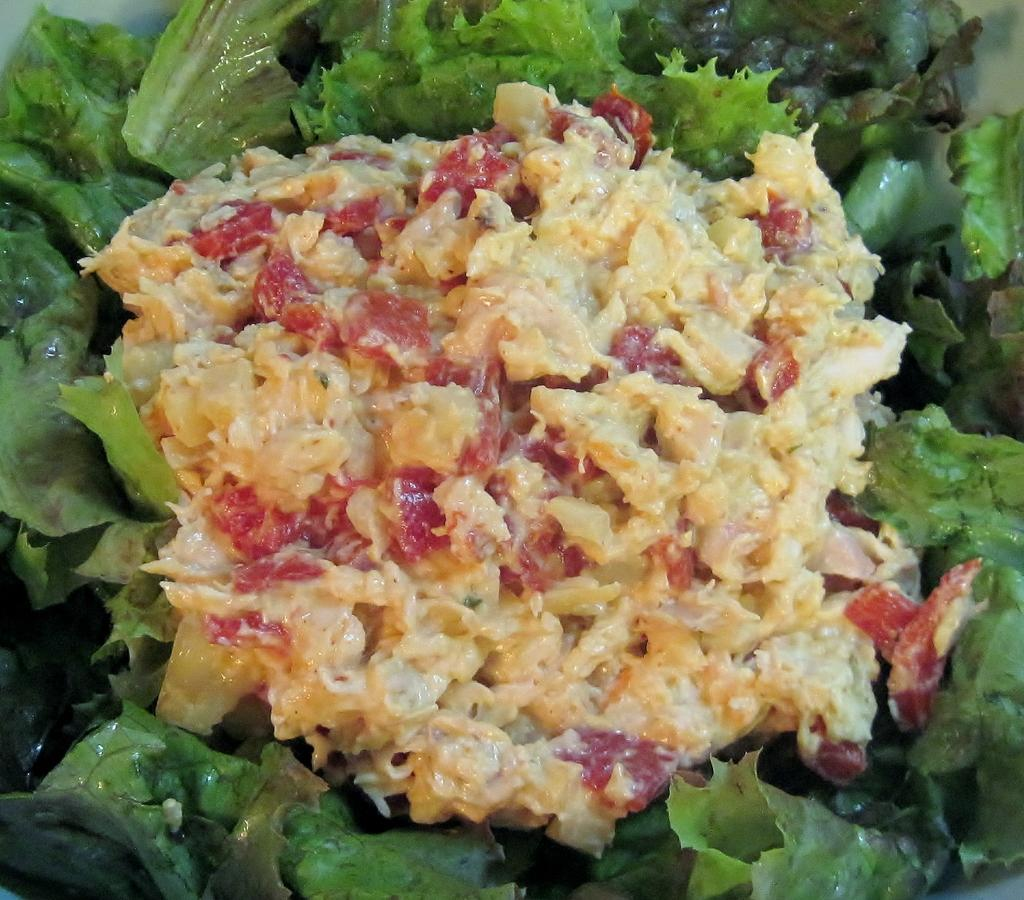What is the main subject of the image? The main subject of the image is food. What can be seen around the food in the image? There are green leaves surrounding the food. Is the farmer playing basketball with the poisonous food in the image? There is no farmer, basketball, or poisonous food present in the image. 